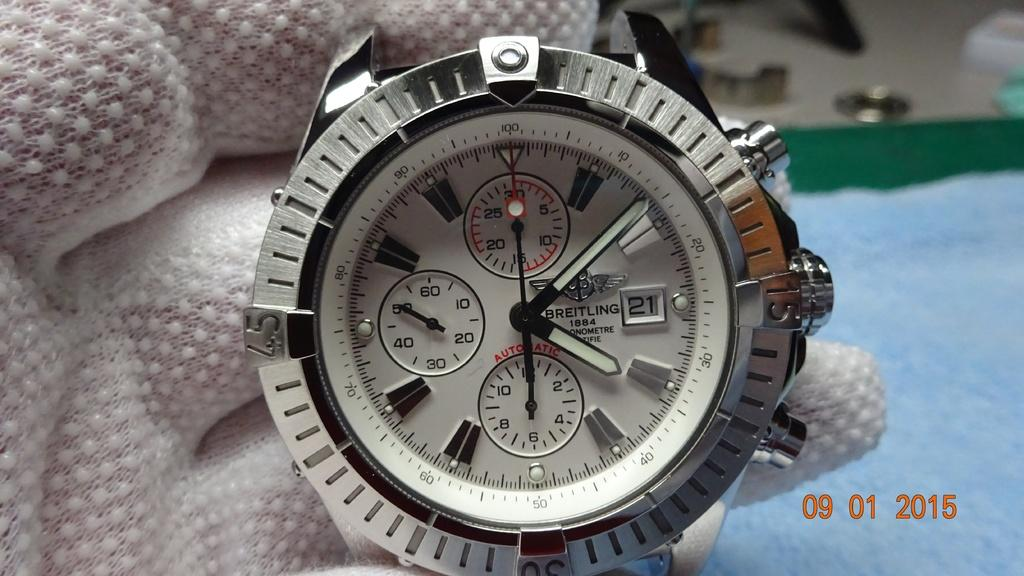<image>
Present a compact description of the photo's key features. Face of a wristwatch which says BREITLING on the face between the hands. 